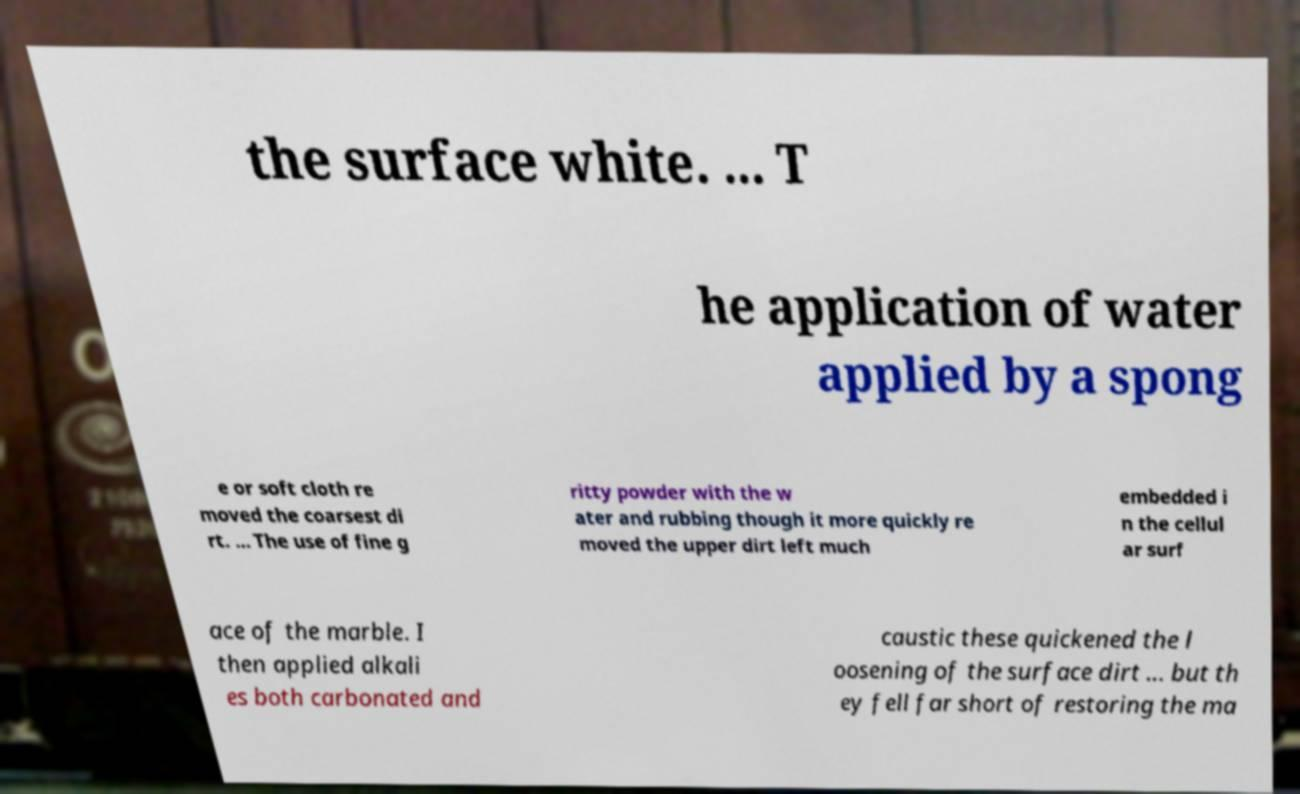Could you assist in decoding the text presented in this image and type it out clearly? the surface white. ... T he application of water applied by a spong e or soft cloth re moved the coarsest di rt. ... The use of fine g ritty powder with the w ater and rubbing though it more quickly re moved the upper dirt left much embedded i n the cellul ar surf ace of the marble. I then applied alkali es both carbonated and caustic these quickened the l oosening of the surface dirt ... but th ey fell far short of restoring the ma 